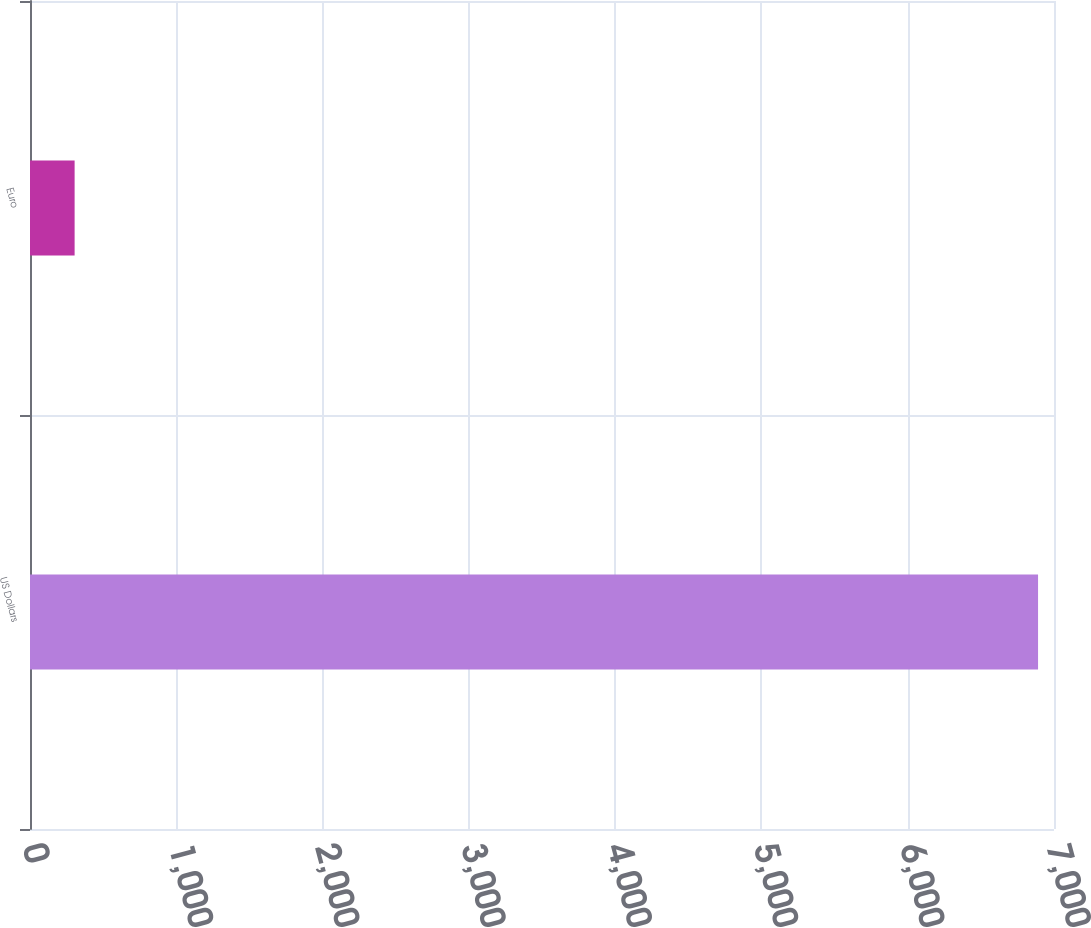Convert chart to OTSL. <chart><loc_0><loc_0><loc_500><loc_500><bar_chart><fcel>US Dollars<fcel>Euro<nl><fcel>6891<fcel>305<nl></chart> 